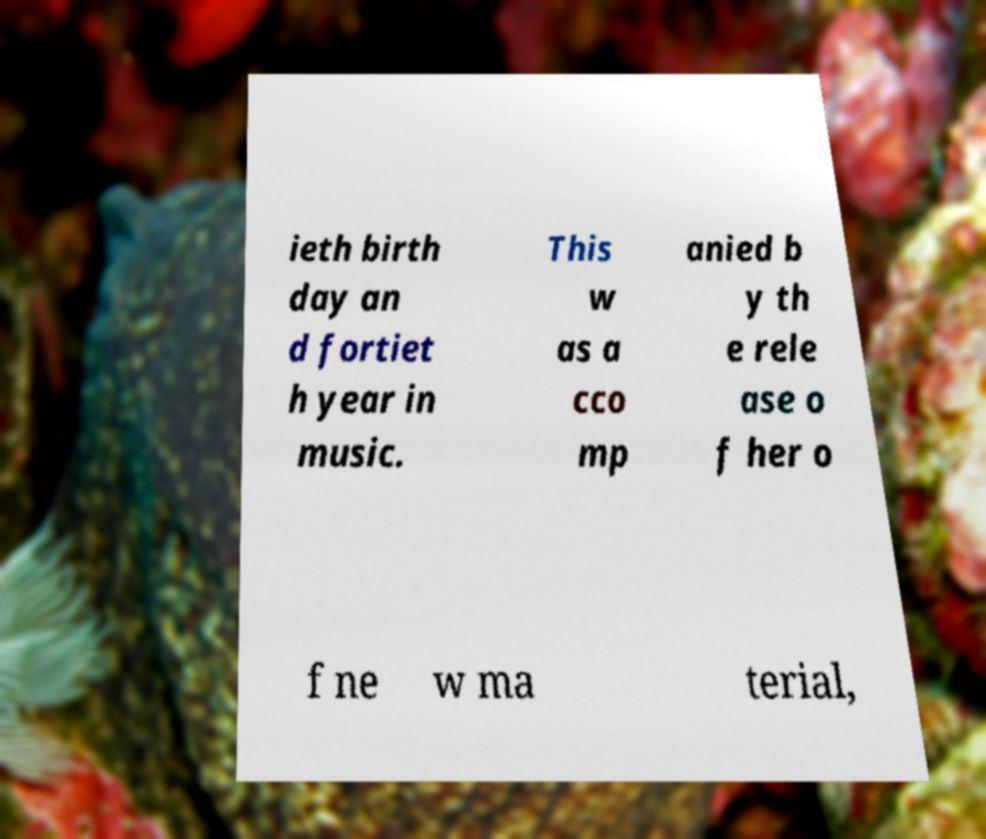Could you assist in decoding the text presented in this image and type it out clearly? ieth birth day an d fortiet h year in music. This w as a cco mp anied b y th e rele ase o f her o f ne w ma terial, 